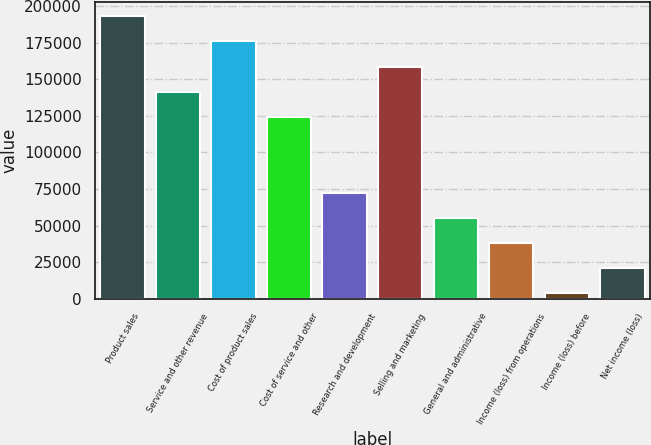<chart> <loc_0><loc_0><loc_500><loc_500><bar_chart><fcel>Product sales<fcel>Service and other revenue<fcel>Cost of product sales<fcel>Cost of service and other<fcel>Research and development<fcel>Selling and marketing<fcel>General and administrative<fcel>Income (loss) from operations<fcel>Income (loss) before<fcel>Net income (loss)<nl><fcel>192972<fcel>141365<fcel>175770<fcel>124163<fcel>72556.2<fcel>158568<fcel>55353.9<fcel>38151.6<fcel>3747<fcel>20949.3<nl></chart> 